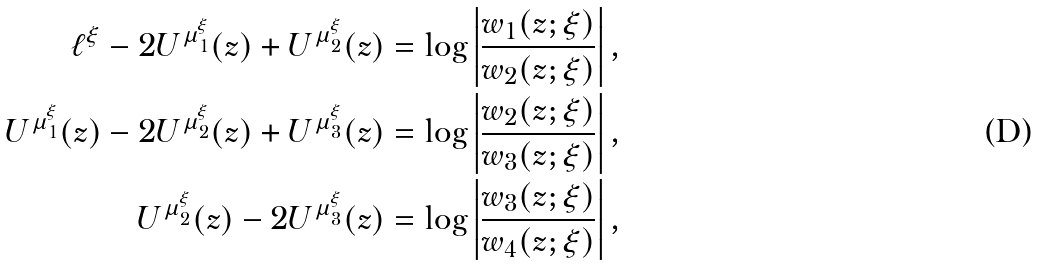Convert formula to latex. <formula><loc_0><loc_0><loc_500><loc_500>\ell ^ { \xi } - 2 U ^ { \mu _ { 1 } ^ { \xi } } ( z ) + U ^ { \mu _ { 2 } ^ { \xi } } ( z ) & = \log \left | \frac { w _ { 1 } ( z ; \xi ) } { w _ { 2 } ( z ; \xi ) } \right | , \\ U ^ { \mu _ { 1 } ^ { \xi } } ( z ) - 2 U ^ { \mu _ { 2 } ^ { \xi } } ( z ) + U ^ { \mu _ { 3 } ^ { \xi } } ( z ) & = \log \left | \frac { w _ { 2 } ( z ; \xi ) } { w _ { 3 } ( z ; \xi ) } \right | , \\ U ^ { \mu _ { 2 } ^ { \xi } } ( z ) - 2 U ^ { \mu _ { 3 } ^ { \xi } } ( z ) & = \log \left | \frac { w _ { 3 } ( z ; \xi ) } { w _ { 4 } ( z ; \xi ) } \right | ,</formula> 